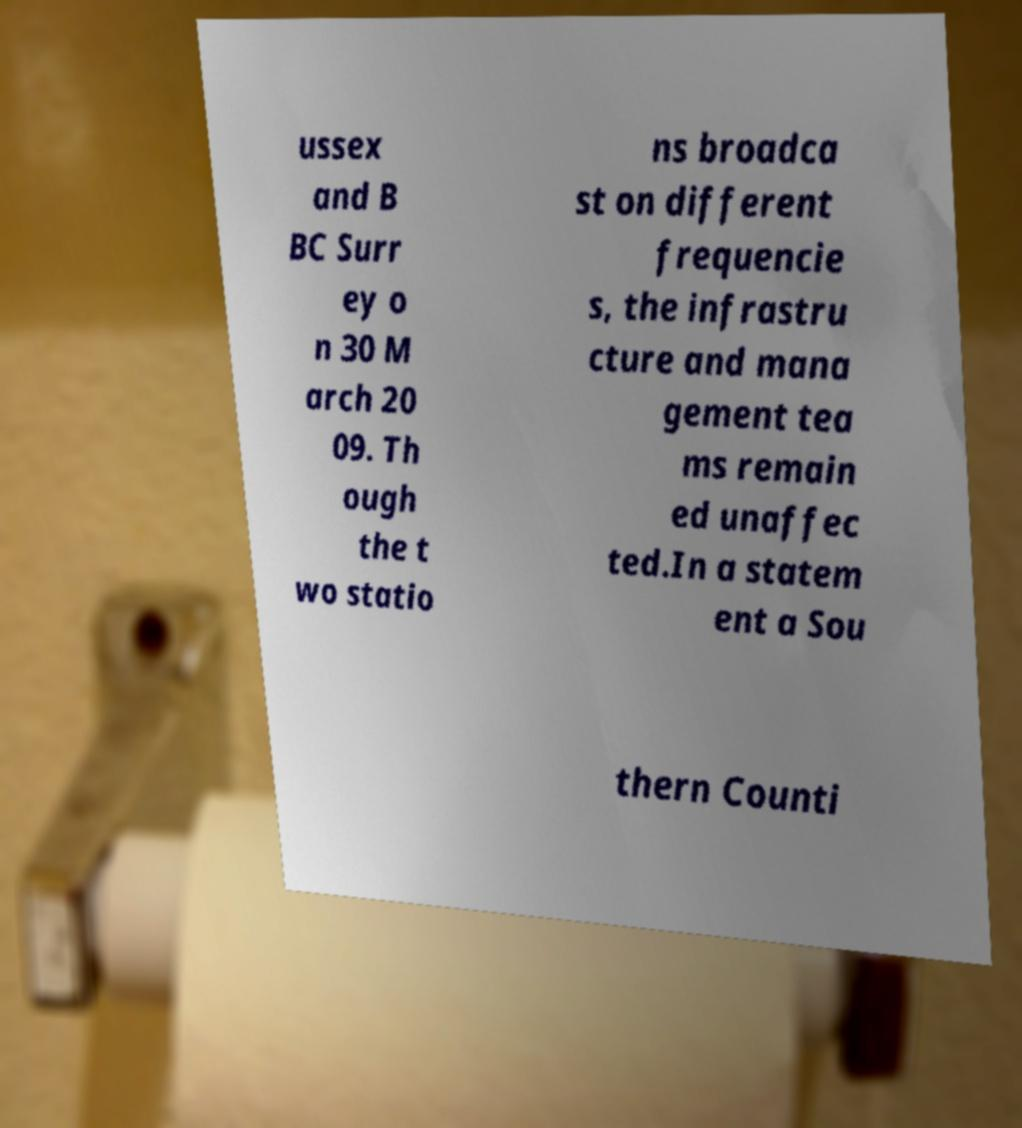Please identify and transcribe the text found in this image. ussex and B BC Surr ey o n 30 M arch 20 09. Th ough the t wo statio ns broadca st on different frequencie s, the infrastru cture and mana gement tea ms remain ed unaffec ted.In a statem ent a Sou thern Counti 